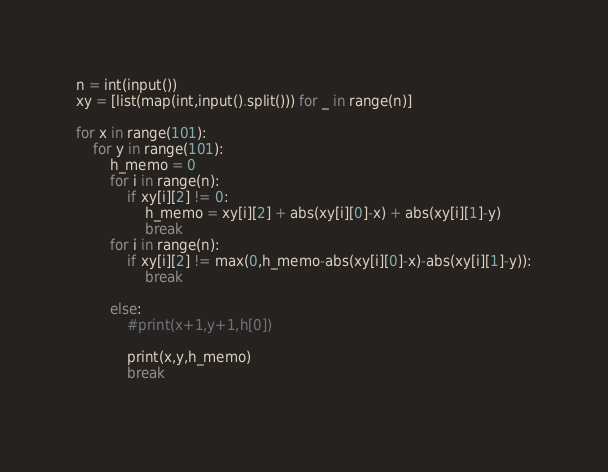<code> <loc_0><loc_0><loc_500><loc_500><_Python_>n = int(input())
xy = [list(map(int,input().split())) for _ in range(n)]

for x in range(101):
    for y in range(101):
        h_memo = 0
        for i in range(n):
            if xy[i][2] != 0:
                h_memo = xy[i][2] + abs(xy[i][0]-x) + abs(xy[i][1]-y)
                break
        for i in range(n):
            if xy[i][2] != max(0,h_memo-abs(xy[i][0]-x)-abs(xy[i][1]-y)):
                break

        else:               
            #print(x+1,y+1,h[0])

            print(x,y,h_memo)
            break
                
</code> 